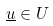Convert formula to latex. <formula><loc_0><loc_0><loc_500><loc_500>\underline { u } \in U</formula> 